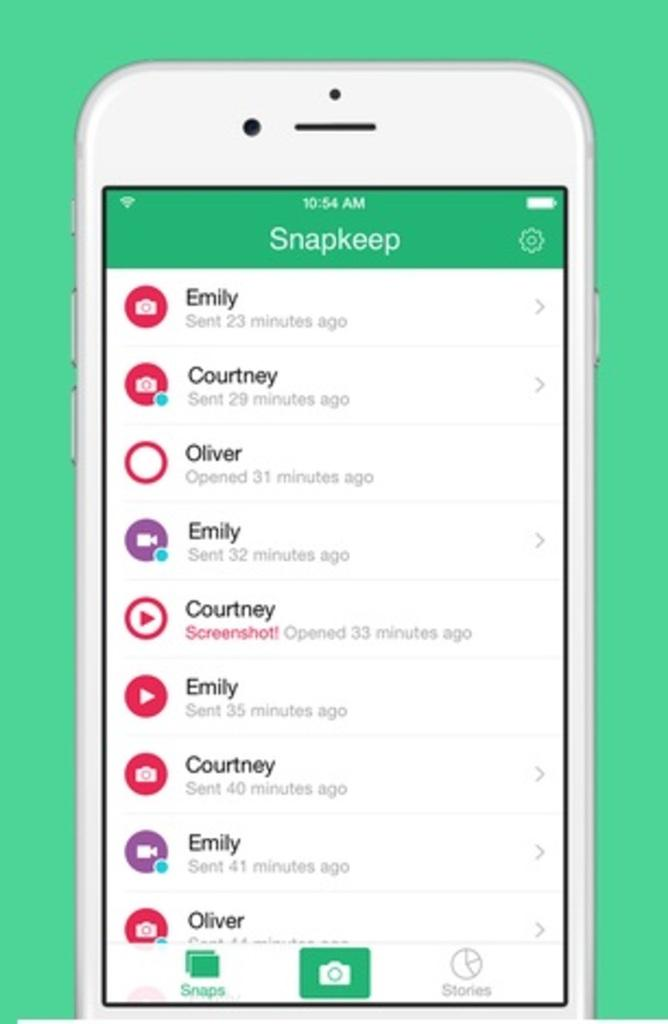<image>
Describe the image concisely. a phone screen with the title 'snapkeep' on the screen, with a bunch of names 